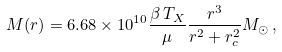<formula> <loc_0><loc_0><loc_500><loc_500>M ( r ) = 6 . 6 8 \times 1 0 ^ { 1 0 } \frac { \beta \, T _ { X } } { \mu } \frac { r ^ { 3 } } { r ^ { 2 } + r _ { c } ^ { 2 } } M _ { \odot } \, ,</formula> 